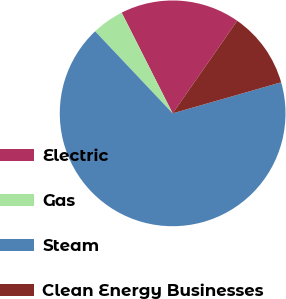<chart> <loc_0><loc_0><loc_500><loc_500><pie_chart><fcel>Electric<fcel>Gas<fcel>Steam<fcel>Clean Energy Businesses<nl><fcel>17.15%<fcel>4.59%<fcel>67.38%<fcel>10.87%<nl></chart> 